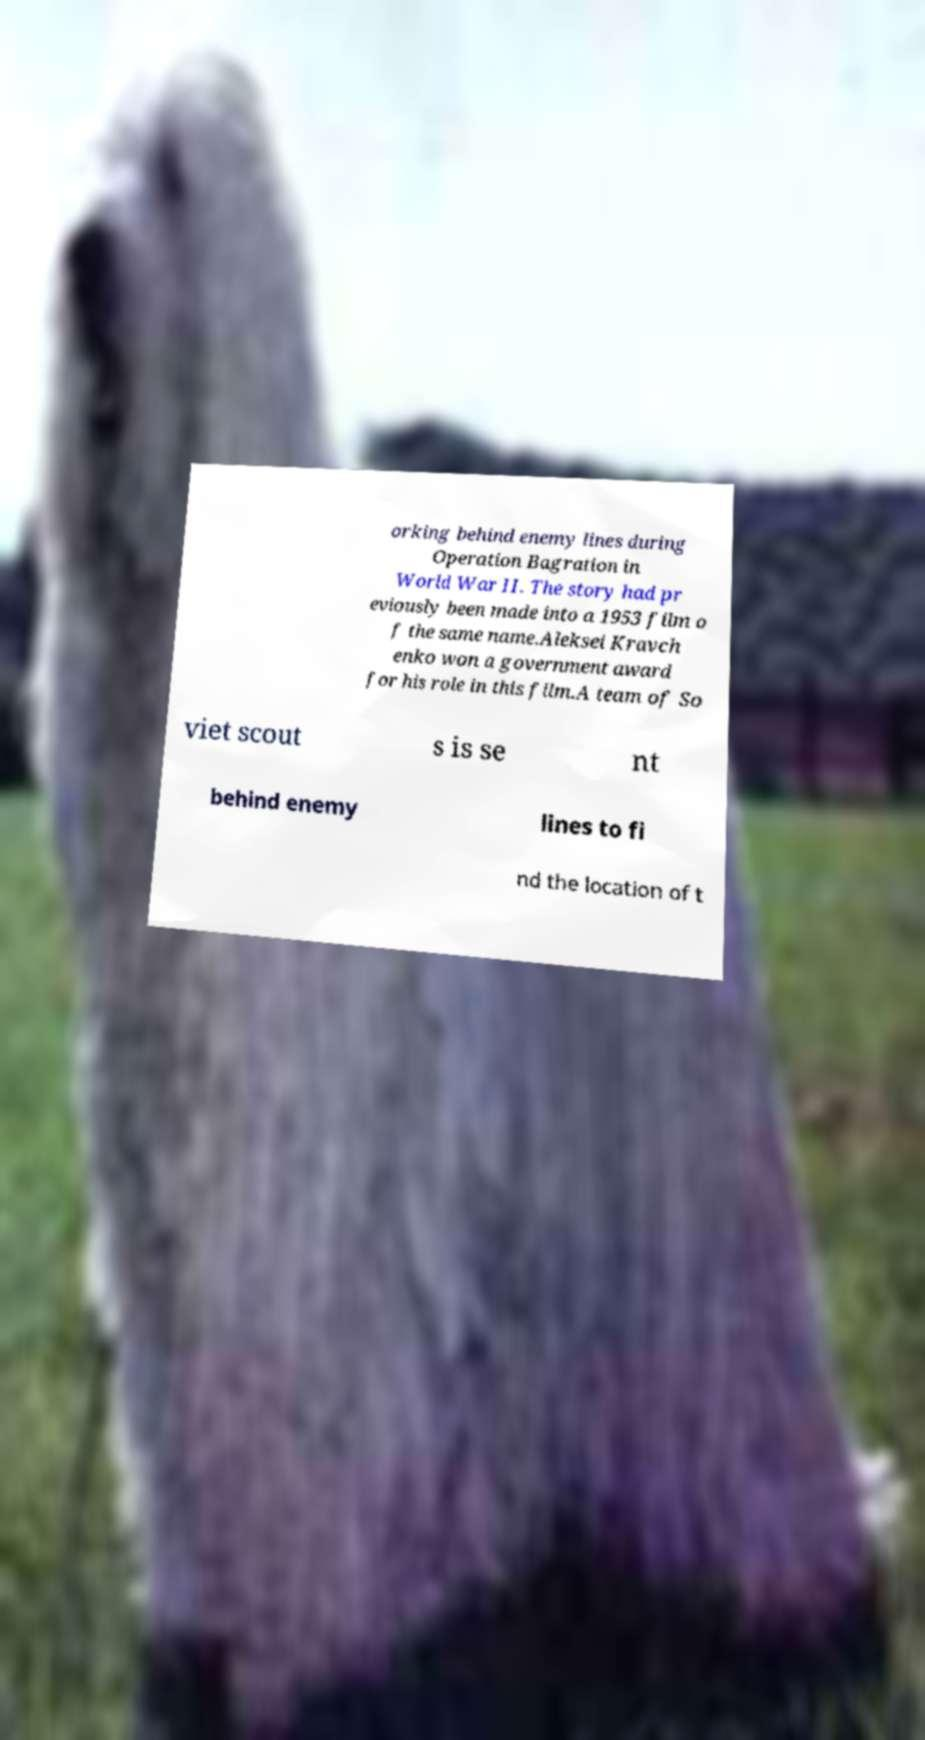For documentation purposes, I need the text within this image transcribed. Could you provide that? orking behind enemy lines during Operation Bagration in World War II. The story had pr eviously been made into a 1953 film o f the same name.Aleksei Kravch enko won a government award for his role in this film.A team of So viet scout s is se nt behind enemy lines to fi nd the location of t 